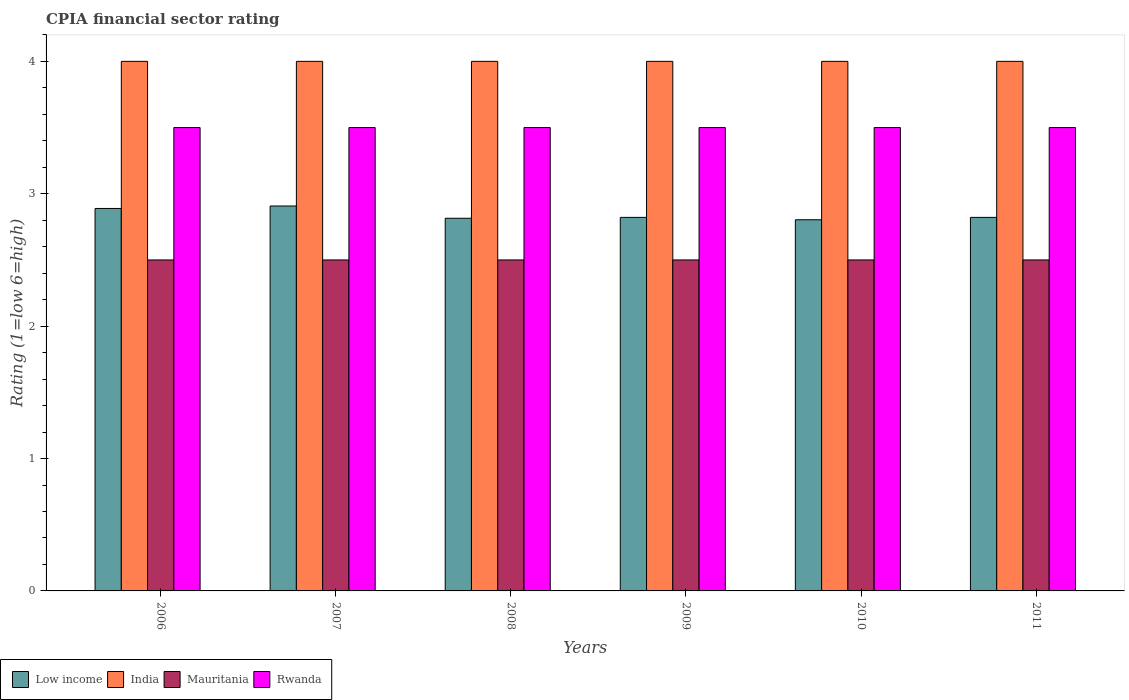How many different coloured bars are there?
Your response must be concise. 4. How many groups of bars are there?
Your response must be concise. 6. How many bars are there on the 4th tick from the right?
Provide a succinct answer. 4. In how many cases, is the number of bars for a given year not equal to the number of legend labels?
Make the answer very short. 0. What is the CPIA rating in Rwanda in 2008?
Keep it short and to the point. 3.5. What is the difference between the CPIA rating in Low income in 2008 and the CPIA rating in Mauritania in 2006?
Your response must be concise. 0.31. In the year 2011, what is the difference between the CPIA rating in India and CPIA rating in Low income?
Make the answer very short. 1.18. What is the ratio of the CPIA rating in Rwanda in 2006 to that in 2011?
Your response must be concise. 1. Is the CPIA rating in Rwanda in 2010 less than that in 2011?
Provide a succinct answer. No. What is the difference between the highest and the lowest CPIA rating in Low income?
Offer a very short reply. 0.1. Is the sum of the CPIA rating in Mauritania in 2007 and 2008 greater than the maximum CPIA rating in Low income across all years?
Provide a succinct answer. Yes. Is it the case that in every year, the sum of the CPIA rating in India and CPIA rating in Low income is greater than the sum of CPIA rating in Rwanda and CPIA rating in Mauritania?
Your answer should be very brief. Yes. What does the 2nd bar from the left in 2011 represents?
Provide a short and direct response. India. What does the 4th bar from the right in 2006 represents?
Provide a succinct answer. Low income. How many bars are there?
Your response must be concise. 24. What is the difference between two consecutive major ticks on the Y-axis?
Offer a terse response. 1. Are the values on the major ticks of Y-axis written in scientific E-notation?
Make the answer very short. No. Where does the legend appear in the graph?
Provide a succinct answer. Bottom left. How many legend labels are there?
Offer a terse response. 4. How are the legend labels stacked?
Offer a terse response. Horizontal. What is the title of the graph?
Keep it short and to the point. CPIA financial sector rating. What is the Rating (1=low 6=high) in Low income in 2006?
Your response must be concise. 2.89. What is the Rating (1=low 6=high) of Low income in 2007?
Make the answer very short. 2.91. What is the Rating (1=low 6=high) in India in 2007?
Make the answer very short. 4. What is the Rating (1=low 6=high) of Low income in 2008?
Your response must be concise. 2.81. What is the Rating (1=low 6=high) in India in 2008?
Provide a succinct answer. 4. What is the Rating (1=low 6=high) in Mauritania in 2008?
Make the answer very short. 2.5. What is the Rating (1=low 6=high) in Rwanda in 2008?
Provide a succinct answer. 3.5. What is the Rating (1=low 6=high) of Low income in 2009?
Offer a terse response. 2.82. What is the Rating (1=low 6=high) of Rwanda in 2009?
Make the answer very short. 3.5. What is the Rating (1=low 6=high) of Low income in 2010?
Provide a short and direct response. 2.8. What is the Rating (1=low 6=high) in Mauritania in 2010?
Offer a terse response. 2.5. What is the Rating (1=low 6=high) in Rwanda in 2010?
Offer a very short reply. 3.5. What is the Rating (1=low 6=high) in Low income in 2011?
Your answer should be compact. 2.82. What is the Rating (1=low 6=high) of Mauritania in 2011?
Your answer should be compact. 2.5. What is the Rating (1=low 6=high) in Rwanda in 2011?
Your response must be concise. 3.5. Across all years, what is the maximum Rating (1=low 6=high) in Low income?
Offer a terse response. 2.91. Across all years, what is the maximum Rating (1=low 6=high) of Mauritania?
Keep it short and to the point. 2.5. Across all years, what is the minimum Rating (1=low 6=high) of Low income?
Make the answer very short. 2.8. Across all years, what is the minimum Rating (1=low 6=high) in Rwanda?
Ensure brevity in your answer.  3.5. What is the total Rating (1=low 6=high) in Low income in the graph?
Provide a short and direct response. 17.06. What is the total Rating (1=low 6=high) of Rwanda in the graph?
Make the answer very short. 21. What is the difference between the Rating (1=low 6=high) in Low income in 2006 and that in 2007?
Your answer should be compact. -0.02. What is the difference between the Rating (1=low 6=high) of Mauritania in 2006 and that in 2007?
Your answer should be compact. 0. What is the difference between the Rating (1=low 6=high) in Rwanda in 2006 and that in 2007?
Provide a succinct answer. 0. What is the difference between the Rating (1=low 6=high) in Low income in 2006 and that in 2008?
Keep it short and to the point. 0.07. What is the difference between the Rating (1=low 6=high) of Low income in 2006 and that in 2009?
Give a very brief answer. 0.07. What is the difference between the Rating (1=low 6=high) of India in 2006 and that in 2009?
Offer a terse response. 0. What is the difference between the Rating (1=low 6=high) of Rwanda in 2006 and that in 2009?
Ensure brevity in your answer.  0. What is the difference between the Rating (1=low 6=high) of Low income in 2006 and that in 2010?
Your response must be concise. 0.09. What is the difference between the Rating (1=low 6=high) in India in 2006 and that in 2010?
Offer a very short reply. 0. What is the difference between the Rating (1=low 6=high) in Low income in 2006 and that in 2011?
Your answer should be compact. 0.07. What is the difference between the Rating (1=low 6=high) of India in 2006 and that in 2011?
Ensure brevity in your answer.  0. What is the difference between the Rating (1=low 6=high) in Mauritania in 2006 and that in 2011?
Give a very brief answer. 0. What is the difference between the Rating (1=low 6=high) of Rwanda in 2006 and that in 2011?
Give a very brief answer. 0. What is the difference between the Rating (1=low 6=high) in Low income in 2007 and that in 2008?
Make the answer very short. 0.09. What is the difference between the Rating (1=low 6=high) in India in 2007 and that in 2008?
Make the answer very short. 0. What is the difference between the Rating (1=low 6=high) of Mauritania in 2007 and that in 2008?
Offer a terse response. 0. What is the difference between the Rating (1=low 6=high) of Rwanda in 2007 and that in 2008?
Your answer should be compact. 0. What is the difference between the Rating (1=low 6=high) of Low income in 2007 and that in 2009?
Your answer should be compact. 0.09. What is the difference between the Rating (1=low 6=high) of India in 2007 and that in 2009?
Offer a very short reply. 0. What is the difference between the Rating (1=low 6=high) in Rwanda in 2007 and that in 2009?
Offer a very short reply. 0. What is the difference between the Rating (1=low 6=high) in Low income in 2007 and that in 2010?
Ensure brevity in your answer.  0.1. What is the difference between the Rating (1=low 6=high) in India in 2007 and that in 2010?
Offer a terse response. 0. What is the difference between the Rating (1=low 6=high) in Low income in 2007 and that in 2011?
Make the answer very short. 0.09. What is the difference between the Rating (1=low 6=high) in India in 2007 and that in 2011?
Your response must be concise. 0. What is the difference between the Rating (1=low 6=high) in Mauritania in 2007 and that in 2011?
Offer a very short reply. 0. What is the difference between the Rating (1=low 6=high) of Rwanda in 2007 and that in 2011?
Your response must be concise. 0. What is the difference between the Rating (1=low 6=high) in Low income in 2008 and that in 2009?
Ensure brevity in your answer.  -0.01. What is the difference between the Rating (1=low 6=high) of India in 2008 and that in 2009?
Provide a succinct answer. 0. What is the difference between the Rating (1=low 6=high) of Mauritania in 2008 and that in 2009?
Your response must be concise. 0. What is the difference between the Rating (1=low 6=high) of Low income in 2008 and that in 2010?
Make the answer very short. 0.01. What is the difference between the Rating (1=low 6=high) in Rwanda in 2008 and that in 2010?
Give a very brief answer. 0. What is the difference between the Rating (1=low 6=high) of Low income in 2008 and that in 2011?
Give a very brief answer. -0.01. What is the difference between the Rating (1=low 6=high) of India in 2008 and that in 2011?
Make the answer very short. 0. What is the difference between the Rating (1=low 6=high) of Rwanda in 2008 and that in 2011?
Offer a very short reply. 0. What is the difference between the Rating (1=low 6=high) of Low income in 2009 and that in 2010?
Provide a short and direct response. 0.02. What is the difference between the Rating (1=low 6=high) of India in 2009 and that in 2010?
Make the answer very short. 0. What is the difference between the Rating (1=low 6=high) of India in 2009 and that in 2011?
Provide a succinct answer. 0. What is the difference between the Rating (1=low 6=high) of Mauritania in 2009 and that in 2011?
Your answer should be compact. 0. What is the difference between the Rating (1=low 6=high) in Rwanda in 2009 and that in 2011?
Give a very brief answer. 0. What is the difference between the Rating (1=low 6=high) of Low income in 2010 and that in 2011?
Make the answer very short. -0.02. What is the difference between the Rating (1=low 6=high) in India in 2010 and that in 2011?
Your answer should be compact. 0. What is the difference between the Rating (1=low 6=high) of Rwanda in 2010 and that in 2011?
Keep it short and to the point. 0. What is the difference between the Rating (1=low 6=high) in Low income in 2006 and the Rating (1=low 6=high) in India in 2007?
Your answer should be very brief. -1.11. What is the difference between the Rating (1=low 6=high) of Low income in 2006 and the Rating (1=low 6=high) of Mauritania in 2007?
Keep it short and to the point. 0.39. What is the difference between the Rating (1=low 6=high) of Low income in 2006 and the Rating (1=low 6=high) of Rwanda in 2007?
Give a very brief answer. -0.61. What is the difference between the Rating (1=low 6=high) of India in 2006 and the Rating (1=low 6=high) of Rwanda in 2007?
Ensure brevity in your answer.  0.5. What is the difference between the Rating (1=low 6=high) of Mauritania in 2006 and the Rating (1=low 6=high) of Rwanda in 2007?
Your response must be concise. -1. What is the difference between the Rating (1=low 6=high) in Low income in 2006 and the Rating (1=low 6=high) in India in 2008?
Provide a succinct answer. -1.11. What is the difference between the Rating (1=low 6=high) in Low income in 2006 and the Rating (1=low 6=high) in Mauritania in 2008?
Provide a short and direct response. 0.39. What is the difference between the Rating (1=low 6=high) in Low income in 2006 and the Rating (1=low 6=high) in Rwanda in 2008?
Ensure brevity in your answer.  -0.61. What is the difference between the Rating (1=low 6=high) in Low income in 2006 and the Rating (1=low 6=high) in India in 2009?
Ensure brevity in your answer.  -1.11. What is the difference between the Rating (1=low 6=high) in Low income in 2006 and the Rating (1=low 6=high) in Mauritania in 2009?
Ensure brevity in your answer.  0.39. What is the difference between the Rating (1=low 6=high) of Low income in 2006 and the Rating (1=low 6=high) of Rwanda in 2009?
Your answer should be very brief. -0.61. What is the difference between the Rating (1=low 6=high) of Low income in 2006 and the Rating (1=low 6=high) of India in 2010?
Make the answer very short. -1.11. What is the difference between the Rating (1=low 6=high) in Low income in 2006 and the Rating (1=low 6=high) in Mauritania in 2010?
Provide a succinct answer. 0.39. What is the difference between the Rating (1=low 6=high) in Low income in 2006 and the Rating (1=low 6=high) in Rwanda in 2010?
Provide a succinct answer. -0.61. What is the difference between the Rating (1=low 6=high) of India in 2006 and the Rating (1=low 6=high) of Rwanda in 2010?
Provide a succinct answer. 0.5. What is the difference between the Rating (1=low 6=high) of Low income in 2006 and the Rating (1=low 6=high) of India in 2011?
Provide a short and direct response. -1.11. What is the difference between the Rating (1=low 6=high) in Low income in 2006 and the Rating (1=low 6=high) in Mauritania in 2011?
Keep it short and to the point. 0.39. What is the difference between the Rating (1=low 6=high) of Low income in 2006 and the Rating (1=low 6=high) of Rwanda in 2011?
Ensure brevity in your answer.  -0.61. What is the difference between the Rating (1=low 6=high) in India in 2006 and the Rating (1=low 6=high) in Rwanda in 2011?
Your answer should be compact. 0.5. What is the difference between the Rating (1=low 6=high) in Low income in 2007 and the Rating (1=low 6=high) in India in 2008?
Keep it short and to the point. -1.09. What is the difference between the Rating (1=low 6=high) in Low income in 2007 and the Rating (1=low 6=high) in Mauritania in 2008?
Make the answer very short. 0.41. What is the difference between the Rating (1=low 6=high) in Low income in 2007 and the Rating (1=low 6=high) in Rwanda in 2008?
Ensure brevity in your answer.  -0.59. What is the difference between the Rating (1=low 6=high) of Mauritania in 2007 and the Rating (1=low 6=high) of Rwanda in 2008?
Ensure brevity in your answer.  -1. What is the difference between the Rating (1=low 6=high) in Low income in 2007 and the Rating (1=low 6=high) in India in 2009?
Offer a very short reply. -1.09. What is the difference between the Rating (1=low 6=high) of Low income in 2007 and the Rating (1=low 6=high) of Mauritania in 2009?
Give a very brief answer. 0.41. What is the difference between the Rating (1=low 6=high) of Low income in 2007 and the Rating (1=low 6=high) of Rwanda in 2009?
Offer a very short reply. -0.59. What is the difference between the Rating (1=low 6=high) of India in 2007 and the Rating (1=low 6=high) of Mauritania in 2009?
Offer a terse response. 1.5. What is the difference between the Rating (1=low 6=high) in Low income in 2007 and the Rating (1=low 6=high) in India in 2010?
Offer a terse response. -1.09. What is the difference between the Rating (1=low 6=high) of Low income in 2007 and the Rating (1=low 6=high) of Mauritania in 2010?
Your answer should be very brief. 0.41. What is the difference between the Rating (1=low 6=high) in Low income in 2007 and the Rating (1=low 6=high) in Rwanda in 2010?
Offer a terse response. -0.59. What is the difference between the Rating (1=low 6=high) in Mauritania in 2007 and the Rating (1=low 6=high) in Rwanda in 2010?
Offer a terse response. -1. What is the difference between the Rating (1=low 6=high) of Low income in 2007 and the Rating (1=low 6=high) of India in 2011?
Offer a very short reply. -1.09. What is the difference between the Rating (1=low 6=high) of Low income in 2007 and the Rating (1=low 6=high) of Mauritania in 2011?
Provide a short and direct response. 0.41. What is the difference between the Rating (1=low 6=high) of Low income in 2007 and the Rating (1=low 6=high) of Rwanda in 2011?
Make the answer very short. -0.59. What is the difference between the Rating (1=low 6=high) of India in 2007 and the Rating (1=low 6=high) of Mauritania in 2011?
Provide a short and direct response. 1.5. What is the difference between the Rating (1=low 6=high) in Low income in 2008 and the Rating (1=low 6=high) in India in 2009?
Provide a succinct answer. -1.19. What is the difference between the Rating (1=low 6=high) in Low income in 2008 and the Rating (1=low 6=high) in Mauritania in 2009?
Keep it short and to the point. 0.31. What is the difference between the Rating (1=low 6=high) in Low income in 2008 and the Rating (1=low 6=high) in Rwanda in 2009?
Ensure brevity in your answer.  -0.69. What is the difference between the Rating (1=low 6=high) of India in 2008 and the Rating (1=low 6=high) of Rwanda in 2009?
Your answer should be very brief. 0.5. What is the difference between the Rating (1=low 6=high) in Mauritania in 2008 and the Rating (1=low 6=high) in Rwanda in 2009?
Offer a terse response. -1. What is the difference between the Rating (1=low 6=high) in Low income in 2008 and the Rating (1=low 6=high) in India in 2010?
Provide a succinct answer. -1.19. What is the difference between the Rating (1=low 6=high) of Low income in 2008 and the Rating (1=low 6=high) of Mauritania in 2010?
Your answer should be very brief. 0.31. What is the difference between the Rating (1=low 6=high) in Low income in 2008 and the Rating (1=low 6=high) in Rwanda in 2010?
Your response must be concise. -0.69. What is the difference between the Rating (1=low 6=high) of India in 2008 and the Rating (1=low 6=high) of Rwanda in 2010?
Offer a terse response. 0.5. What is the difference between the Rating (1=low 6=high) of Mauritania in 2008 and the Rating (1=low 6=high) of Rwanda in 2010?
Your answer should be compact. -1. What is the difference between the Rating (1=low 6=high) in Low income in 2008 and the Rating (1=low 6=high) in India in 2011?
Your answer should be compact. -1.19. What is the difference between the Rating (1=low 6=high) of Low income in 2008 and the Rating (1=low 6=high) of Mauritania in 2011?
Offer a very short reply. 0.31. What is the difference between the Rating (1=low 6=high) of Low income in 2008 and the Rating (1=low 6=high) of Rwanda in 2011?
Give a very brief answer. -0.69. What is the difference between the Rating (1=low 6=high) of Mauritania in 2008 and the Rating (1=low 6=high) of Rwanda in 2011?
Your answer should be very brief. -1. What is the difference between the Rating (1=low 6=high) of Low income in 2009 and the Rating (1=low 6=high) of India in 2010?
Ensure brevity in your answer.  -1.18. What is the difference between the Rating (1=low 6=high) of Low income in 2009 and the Rating (1=low 6=high) of Mauritania in 2010?
Give a very brief answer. 0.32. What is the difference between the Rating (1=low 6=high) of Low income in 2009 and the Rating (1=low 6=high) of Rwanda in 2010?
Your answer should be compact. -0.68. What is the difference between the Rating (1=low 6=high) in India in 2009 and the Rating (1=low 6=high) in Rwanda in 2010?
Give a very brief answer. 0.5. What is the difference between the Rating (1=low 6=high) of Mauritania in 2009 and the Rating (1=low 6=high) of Rwanda in 2010?
Give a very brief answer. -1. What is the difference between the Rating (1=low 6=high) of Low income in 2009 and the Rating (1=low 6=high) of India in 2011?
Give a very brief answer. -1.18. What is the difference between the Rating (1=low 6=high) of Low income in 2009 and the Rating (1=low 6=high) of Mauritania in 2011?
Offer a very short reply. 0.32. What is the difference between the Rating (1=low 6=high) in Low income in 2009 and the Rating (1=low 6=high) in Rwanda in 2011?
Keep it short and to the point. -0.68. What is the difference between the Rating (1=low 6=high) of India in 2009 and the Rating (1=low 6=high) of Mauritania in 2011?
Your answer should be compact. 1.5. What is the difference between the Rating (1=low 6=high) in India in 2009 and the Rating (1=low 6=high) in Rwanda in 2011?
Your response must be concise. 0.5. What is the difference between the Rating (1=low 6=high) in Low income in 2010 and the Rating (1=low 6=high) in India in 2011?
Your answer should be very brief. -1.2. What is the difference between the Rating (1=low 6=high) of Low income in 2010 and the Rating (1=low 6=high) of Mauritania in 2011?
Give a very brief answer. 0.3. What is the difference between the Rating (1=low 6=high) of Low income in 2010 and the Rating (1=low 6=high) of Rwanda in 2011?
Your answer should be very brief. -0.7. What is the difference between the Rating (1=low 6=high) in India in 2010 and the Rating (1=low 6=high) in Mauritania in 2011?
Provide a succinct answer. 1.5. What is the difference between the Rating (1=low 6=high) in India in 2010 and the Rating (1=low 6=high) in Rwanda in 2011?
Provide a succinct answer. 0.5. What is the average Rating (1=low 6=high) in Low income per year?
Keep it short and to the point. 2.84. In the year 2006, what is the difference between the Rating (1=low 6=high) in Low income and Rating (1=low 6=high) in India?
Provide a short and direct response. -1.11. In the year 2006, what is the difference between the Rating (1=low 6=high) in Low income and Rating (1=low 6=high) in Mauritania?
Give a very brief answer. 0.39. In the year 2006, what is the difference between the Rating (1=low 6=high) of Low income and Rating (1=low 6=high) of Rwanda?
Keep it short and to the point. -0.61. In the year 2006, what is the difference between the Rating (1=low 6=high) in India and Rating (1=low 6=high) in Mauritania?
Give a very brief answer. 1.5. In the year 2006, what is the difference between the Rating (1=low 6=high) of India and Rating (1=low 6=high) of Rwanda?
Your answer should be compact. 0.5. In the year 2007, what is the difference between the Rating (1=low 6=high) of Low income and Rating (1=low 6=high) of India?
Make the answer very short. -1.09. In the year 2007, what is the difference between the Rating (1=low 6=high) of Low income and Rating (1=low 6=high) of Mauritania?
Your answer should be compact. 0.41. In the year 2007, what is the difference between the Rating (1=low 6=high) of Low income and Rating (1=low 6=high) of Rwanda?
Provide a short and direct response. -0.59. In the year 2007, what is the difference between the Rating (1=low 6=high) in India and Rating (1=low 6=high) in Mauritania?
Make the answer very short. 1.5. In the year 2007, what is the difference between the Rating (1=low 6=high) of Mauritania and Rating (1=low 6=high) of Rwanda?
Your answer should be compact. -1. In the year 2008, what is the difference between the Rating (1=low 6=high) of Low income and Rating (1=low 6=high) of India?
Give a very brief answer. -1.19. In the year 2008, what is the difference between the Rating (1=low 6=high) in Low income and Rating (1=low 6=high) in Mauritania?
Make the answer very short. 0.31. In the year 2008, what is the difference between the Rating (1=low 6=high) in Low income and Rating (1=low 6=high) in Rwanda?
Make the answer very short. -0.69. In the year 2008, what is the difference between the Rating (1=low 6=high) in India and Rating (1=low 6=high) in Rwanda?
Your response must be concise. 0.5. In the year 2009, what is the difference between the Rating (1=low 6=high) in Low income and Rating (1=low 6=high) in India?
Offer a very short reply. -1.18. In the year 2009, what is the difference between the Rating (1=low 6=high) of Low income and Rating (1=low 6=high) of Mauritania?
Your answer should be compact. 0.32. In the year 2009, what is the difference between the Rating (1=low 6=high) in Low income and Rating (1=low 6=high) in Rwanda?
Keep it short and to the point. -0.68. In the year 2009, what is the difference between the Rating (1=low 6=high) in Mauritania and Rating (1=low 6=high) in Rwanda?
Your answer should be very brief. -1. In the year 2010, what is the difference between the Rating (1=low 6=high) of Low income and Rating (1=low 6=high) of India?
Offer a terse response. -1.2. In the year 2010, what is the difference between the Rating (1=low 6=high) of Low income and Rating (1=low 6=high) of Mauritania?
Give a very brief answer. 0.3. In the year 2010, what is the difference between the Rating (1=low 6=high) of Low income and Rating (1=low 6=high) of Rwanda?
Provide a succinct answer. -0.7. In the year 2010, what is the difference between the Rating (1=low 6=high) of Mauritania and Rating (1=low 6=high) of Rwanda?
Provide a short and direct response. -1. In the year 2011, what is the difference between the Rating (1=low 6=high) of Low income and Rating (1=low 6=high) of India?
Your response must be concise. -1.18. In the year 2011, what is the difference between the Rating (1=low 6=high) in Low income and Rating (1=low 6=high) in Mauritania?
Make the answer very short. 0.32. In the year 2011, what is the difference between the Rating (1=low 6=high) of Low income and Rating (1=low 6=high) of Rwanda?
Your response must be concise. -0.68. In the year 2011, what is the difference between the Rating (1=low 6=high) of India and Rating (1=low 6=high) of Rwanda?
Provide a short and direct response. 0.5. What is the ratio of the Rating (1=low 6=high) of Low income in 2006 to that in 2007?
Offer a terse response. 0.99. What is the ratio of the Rating (1=low 6=high) of India in 2006 to that in 2007?
Your answer should be compact. 1. What is the ratio of the Rating (1=low 6=high) in Low income in 2006 to that in 2008?
Provide a short and direct response. 1.03. What is the ratio of the Rating (1=low 6=high) in Low income in 2006 to that in 2009?
Provide a short and direct response. 1.02. What is the ratio of the Rating (1=low 6=high) in Mauritania in 2006 to that in 2009?
Make the answer very short. 1. What is the ratio of the Rating (1=low 6=high) of Rwanda in 2006 to that in 2009?
Offer a very short reply. 1. What is the ratio of the Rating (1=low 6=high) of Low income in 2006 to that in 2010?
Ensure brevity in your answer.  1.03. What is the ratio of the Rating (1=low 6=high) of Mauritania in 2006 to that in 2010?
Make the answer very short. 1. What is the ratio of the Rating (1=low 6=high) in Low income in 2006 to that in 2011?
Provide a succinct answer. 1.02. What is the ratio of the Rating (1=low 6=high) in Mauritania in 2006 to that in 2011?
Provide a short and direct response. 1. What is the ratio of the Rating (1=low 6=high) in Rwanda in 2006 to that in 2011?
Offer a very short reply. 1. What is the ratio of the Rating (1=low 6=high) in Low income in 2007 to that in 2008?
Ensure brevity in your answer.  1.03. What is the ratio of the Rating (1=low 6=high) of India in 2007 to that in 2008?
Ensure brevity in your answer.  1. What is the ratio of the Rating (1=low 6=high) of Mauritania in 2007 to that in 2008?
Ensure brevity in your answer.  1. What is the ratio of the Rating (1=low 6=high) of Rwanda in 2007 to that in 2008?
Your answer should be very brief. 1. What is the ratio of the Rating (1=low 6=high) of Low income in 2007 to that in 2009?
Offer a very short reply. 1.03. What is the ratio of the Rating (1=low 6=high) in India in 2007 to that in 2009?
Offer a terse response. 1. What is the ratio of the Rating (1=low 6=high) in India in 2007 to that in 2010?
Make the answer very short. 1. What is the ratio of the Rating (1=low 6=high) of Low income in 2007 to that in 2011?
Keep it short and to the point. 1.03. What is the ratio of the Rating (1=low 6=high) of Rwanda in 2007 to that in 2011?
Make the answer very short. 1. What is the ratio of the Rating (1=low 6=high) of Low income in 2008 to that in 2010?
Your response must be concise. 1. What is the ratio of the Rating (1=low 6=high) in India in 2008 to that in 2010?
Your answer should be compact. 1. What is the ratio of the Rating (1=low 6=high) of Mauritania in 2008 to that in 2010?
Make the answer very short. 1. What is the ratio of the Rating (1=low 6=high) of Rwanda in 2008 to that in 2010?
Offer a terse response. 1. What is the ratio of the Rating (1=low 6=high) of India in 2008 to that in 2011?
Provide a short and direct response. 1. What is the ratio of the Rating (1=low 6=high) in Low income in 2009 to that in 2010?
Provide a short and direct response. 1.01. What is the ratio of the Rating (1=low 6=high) in India in 2009 to that in 2010?
Provide a short and direct response. 1. What is the ratio of the Rating (1=low 6=high) of Rwanda in 2009 to that in 2010?
Give a very brief answer. 1. What is the ratio of the Rating (1=low 6=high) of India in 2009 to that in 2011?
Make the answer very short. 1. What is the ratio of the Rating (1=low 6=high) in Mauritania in 2009 to that in 2011?
Offer a terse response. 1. What is the ratio of the Rating (1=low 6=high) in Low income in 2010 to that in 2011?
Ensure brevity in your answer.  0.99. What is the ratio of the Rating (1=low 6=high) in India in 2010 to that in 2011?
Your answer should be compact. 1. What is the ratio of the Rating (1=low 6=high) of Rwanda in 2010 to that in 2011?
Keep it short and to the point. 1. What is the difference between the highest and the second highest Rating (1=low 6=high) of Low income?
Your answer should be very brief. 0.02. What is the difference between the highest and the second highest Rating (1=low 6=high) in India?
Offer a terse response. 0. What is the difference between the highest and the second highest Rating (1=low 6=high) of Mauritania?
Offer a terse response. 0. What is the difference between the highest and the second highest Rating (1=low 6=high) in Rwanda?
Your answer should be compact. 0. What is the difference between the highest and the lowest Rating (1=low 6=high) of Low income?
Give a very brief answer. 0.1. 